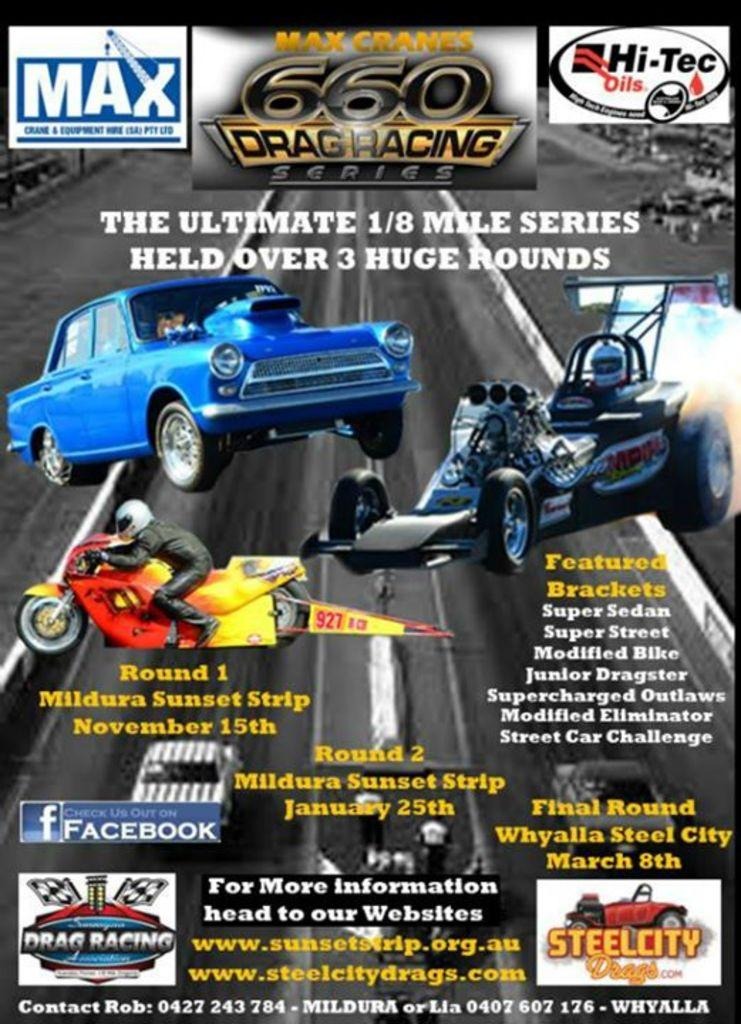What type of visual is the image? The image appears to be a poster. What is featured on the poster? There are vehicles depicted on the poster. Can you describe the person in the image? There is a person sitting on a motorbike. What is the setting of the image? The image shows a road. What else can be seen on the poster besides the vehicles and road? There are letters and logos on the poster. What type of science experiment is being conducted on the motorbike in the image? There is no science experiment being conducted on the motorbike in the image; it simply shows a person sitting on it. What angle is the motorbike leaning at in the image? The angle of the motorbike cannot be determined from the image, as it is not shown in a perspective that would allow for such an assessment. 